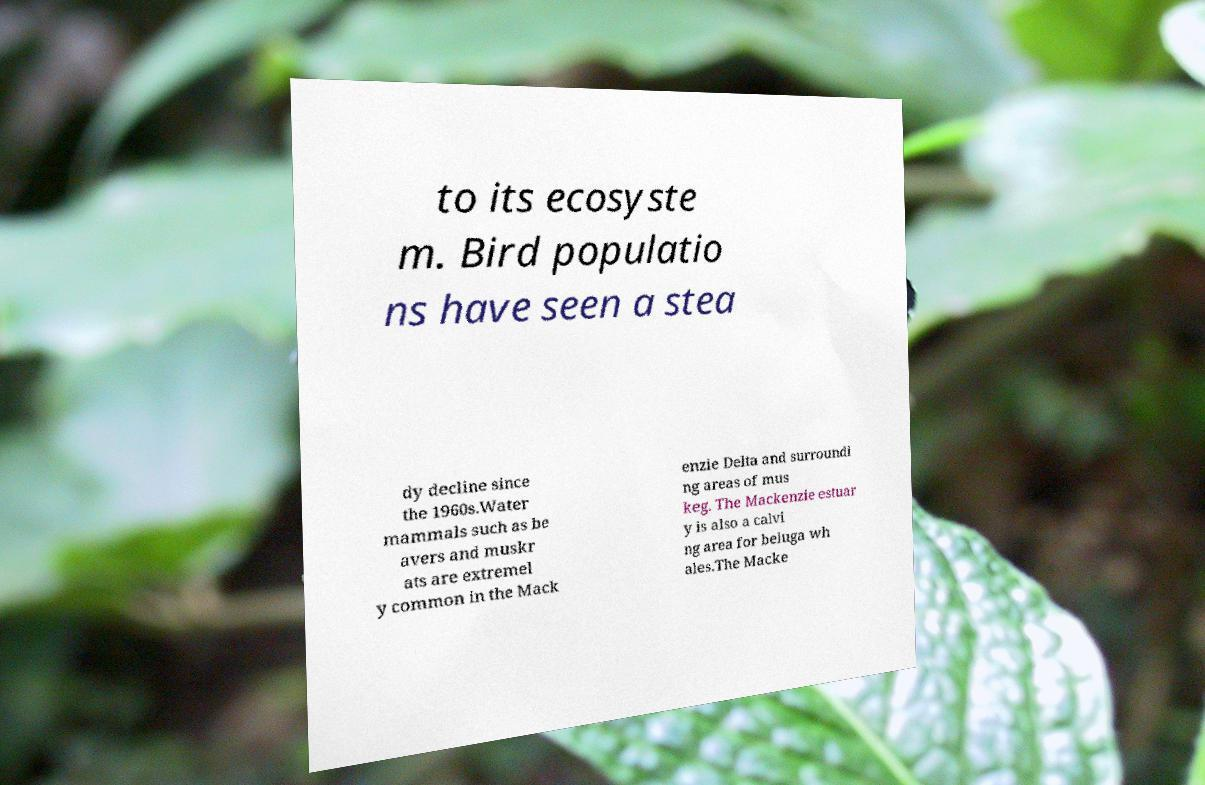Please read and relay the text visible in this image. What does it say? to its ecosyste m. Bird populatio ns have seen a stea dy decline since the 1960s.Water mammals such as be avers and muskr ats are extremel y common in the Mack enzie Delta and surroundi ng areas of mus keg. The Mackenzie estuar y is also a calvi ng area for beluga wh ales.The Macke 